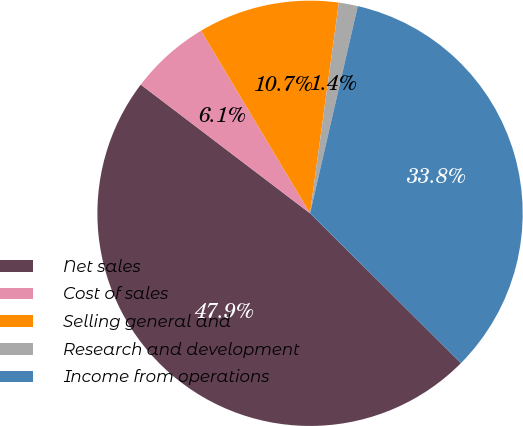Convert chart to OTSL. <chart><loc_0><loc_0><loc_500><loc_500><pie_chart><fcel>Net sales<fcel>Cost of sales<fcel>Selling general and<fcel>Research and development<fcel>Income from operations<nl><fcel>47.9%<fcel>6.09%<fcel>10.73%<fcel>1.44%<fcel>33.84%<nl></chart> 